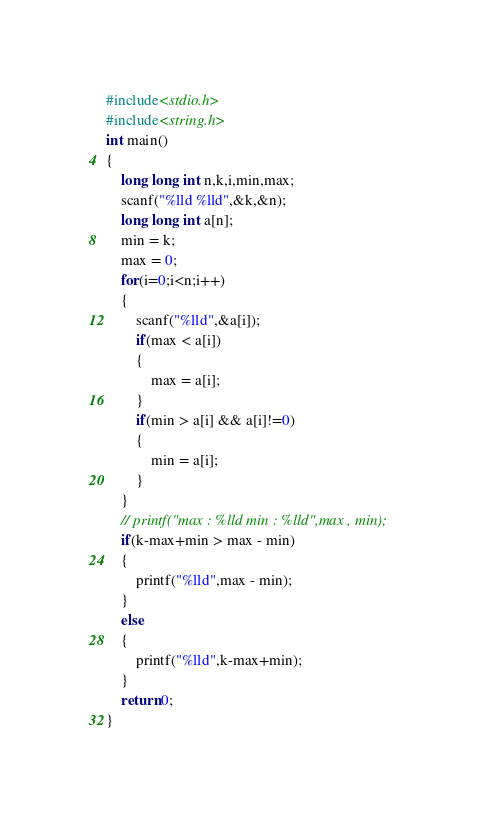<code> <loc_0><loc_0><loc_500><loc_500><_C_>#include<stdio.h>
#include<string.h>
int main()
{
    long long int n,k,i,min,max;
    scanf("%lld %lld",&k,&n);
    long long int a[n];
    min = k;
    max = 0;
    for(i=0;i<n;i++)
    {
        scanf("%lld",&a[i]);
        if(max < a[i])
        {
            max = a[i];
        }
        if(min > a[i] && a[i]!=0)
        {
            min = a[i];
        }
    }
    // printf("max : %lld min : %lld",max , min);
    if(k-max+min > max - min)
    {
        printf("%lld",max - min);
    }
    else
    {
        printf("%lld",k-max+min);
    }
    return 0;
}</code> 